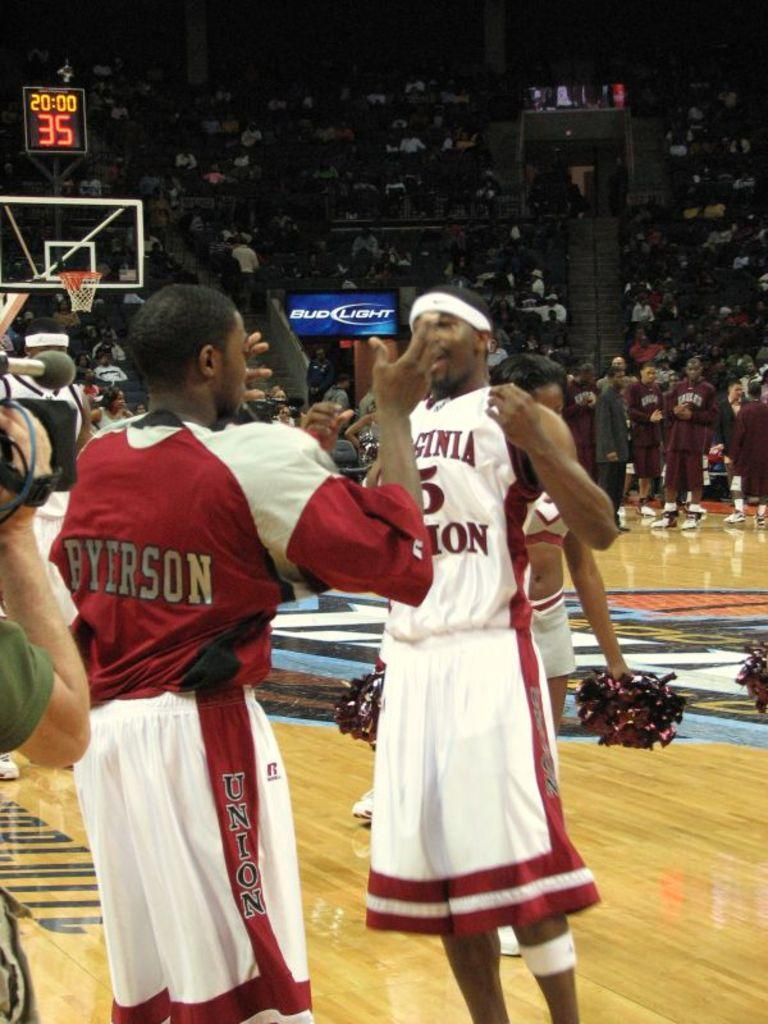<image>
Give a short and clear explanation of the subsequent image. Byerson is interacting with a Virginia basketball player. 